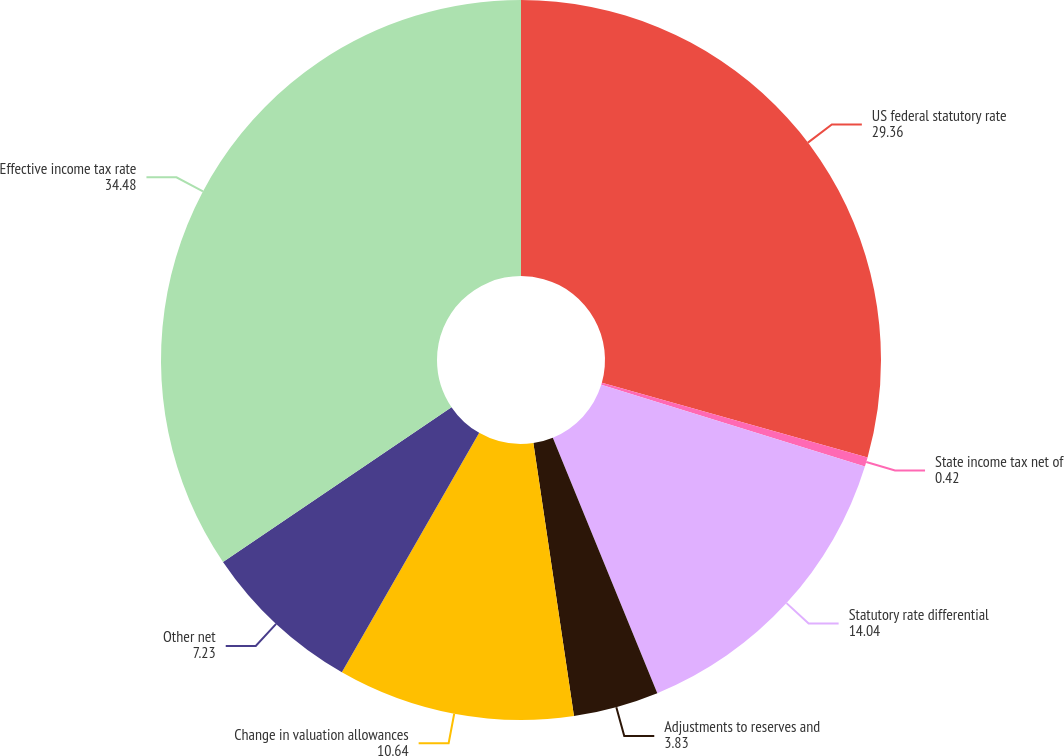<chart> <loc_0><loc_0><loc_500><loc_500><pie_chart><fcel>US federal statutory rate<fcel>State income tax net of<fcel>Statutory rate differential<fcel>Adjustments to reserves and<fcel>Change in valuation allowances<fcel>Other net<fcel>Effective income tax rate<nl><fcel>29.36%<fcel>0.42%<fcel>14.04%<fcel>3.83%<fcel>10.64%<fcel>7.23%<fcel>34.48%<nl></chart> 